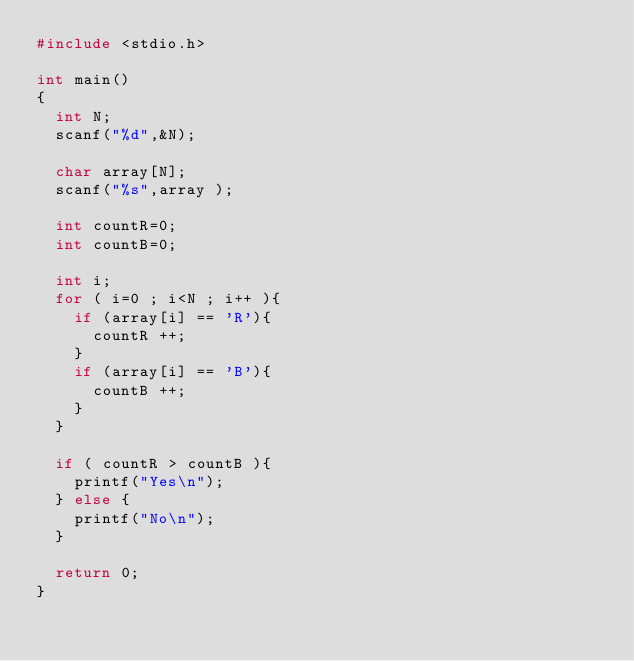Convert code to text. <code><loc_0><loc_0><loc_500><loc_500><_C_>#include <stdio.h>

int main()
{
	int N;
	scanf("%d",&N);

	char array[N];
	scanf("%s",array );

	int countR=0;
	int countB=0;

	int i;
	for ( i=0 ; i<N ; i++	){
		if (array[i] == 'R'){
			countR ++;
		}
		if (array[i] == 'B'){
			countB ++;
		}
	}

	if ( countR > countB ){
		printf("Yes\n");
	} else {
		printf("No\n");
	}

	return 0;
}
</code> 